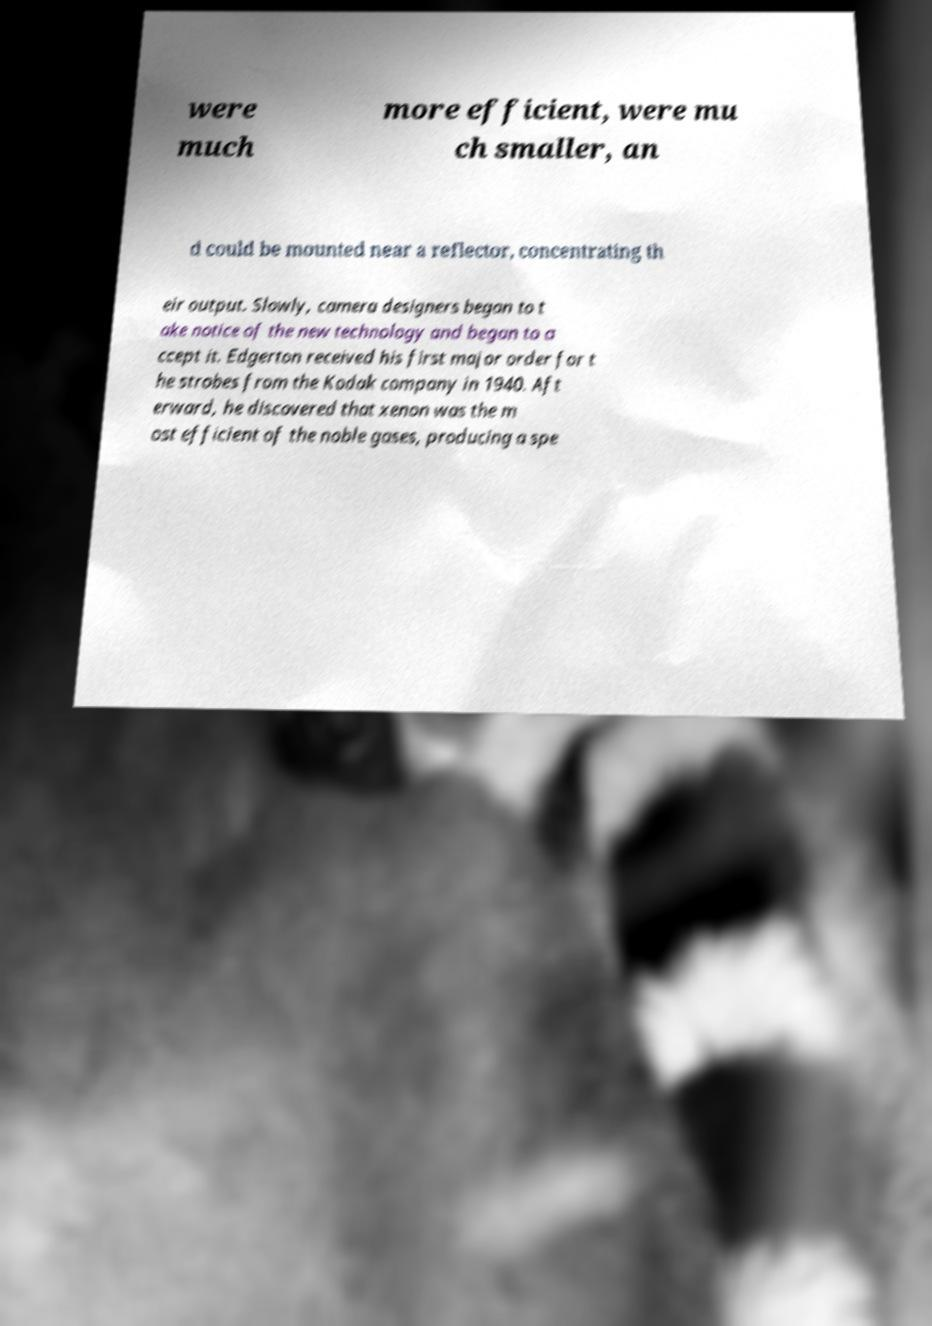Can you accurately transcribe the text from the provided image for me? were much more efficient, were mu ch smaller, an d could be mounted near a reflector, concentrating th eir output. Slowly, camera designers began to t ake notice of the new technology and began to a ccept it. Edgerton received his first major order for t he strobes from the Kodak company in 1940. Aft erward, he discovered that xenon was the m ost efficient of the noble gases, producing a spe 